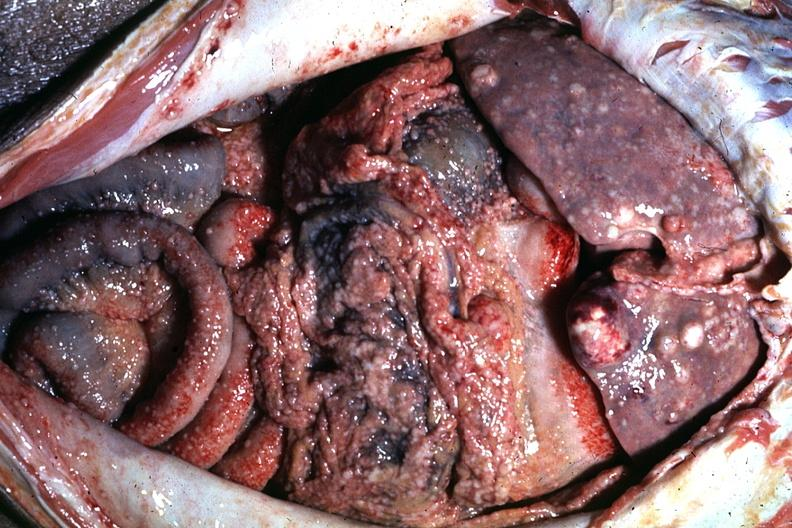s metastatic carcinoma present?
Answer the question using a single word or phrase. Yes 